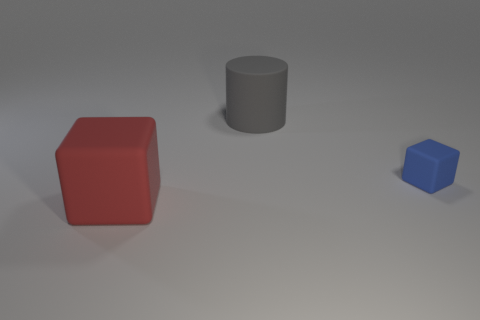There is a cube behind the large red block; is it the same size as the matte block that is in front of the blue rubber object?
Provide a succinct answer. No. Is there anything else that is the same material as the large block?
Offer a terse response. Yes. How many small objects are either cylinders or shiny cylinders?
Make the answer very short. 0. What number of objects are either things in front of the blue object or large blue metal balls?
Your answer should be compact. 1. Do the small cube and the cylinder have the same color?
Offer a terse response. No. How many other things are the same shape as the gray object?
Make the answer very short. 0. What number of gray objects are big cylinders or tiny rubber cubes?
Provide a short and direct response. 1. What color is the large object that is the same material as the big cylinder?
Your response must be concise. Red. Does the big thing behind the red rubber thing have the same material as the block in front of the blue block?
Your response must be concise. Yes. What material is the block that is on the left side of the large gray cylinder?
Provide a short and direct response. Rubber. 